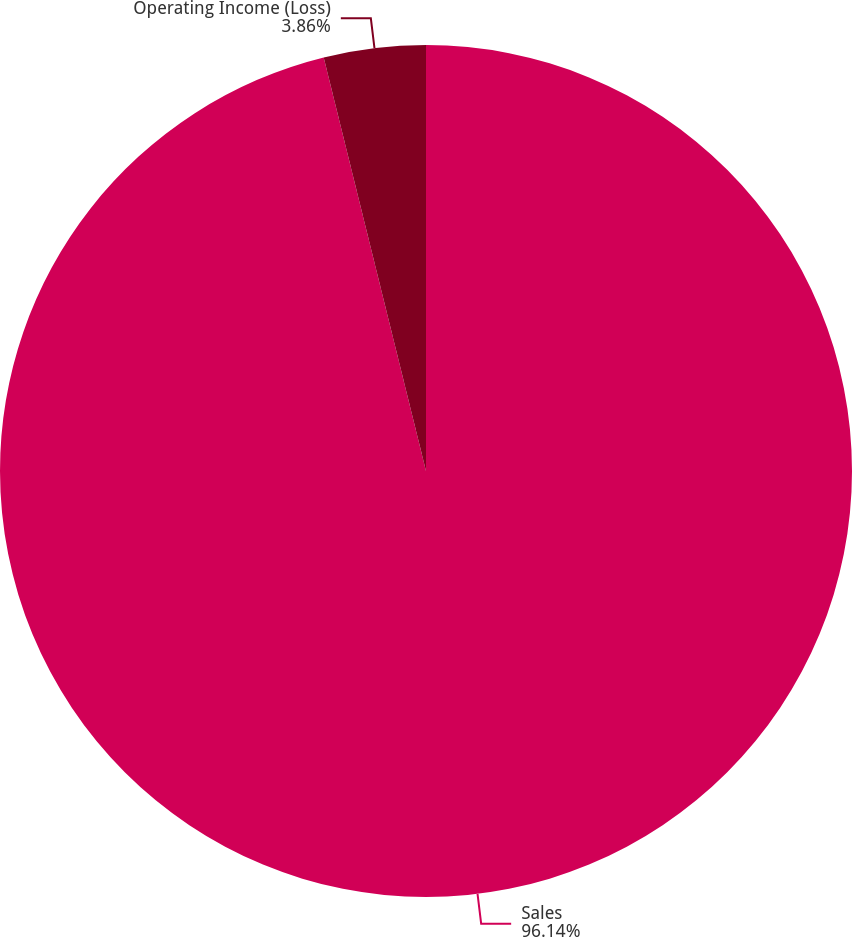Convert chart. <chart><loc_0><loc_0><loc_500><loc_500><pie_chart><fcel>Sales<fcel>Operating Income (Loss)<nl><fcel>96.14%<fcel>3.86%<nl></chart> 